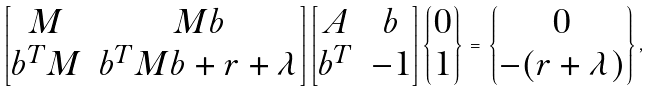<formula> <loc_0><loc_0><loc_500><loc_500>\left [ \begin{matrix} { M } & { M b } \\ { b } ^ { T } { M } & { b } ^ { T } { M b } + r + \lambda \end{matrix} \right ] \left [ \begin{matrix} { A } & { b } \\ { b } ^ { T } & - 1 \end{matrix} \right ] \left \{ \begin{matrix} { 0 } \\ 1 \end{matrix} \right \} \, = \, \left \{ \begin{matrix} { 0 } \\ - ( r + \lambda ) \end{matrix} \right \} ,</formula> 